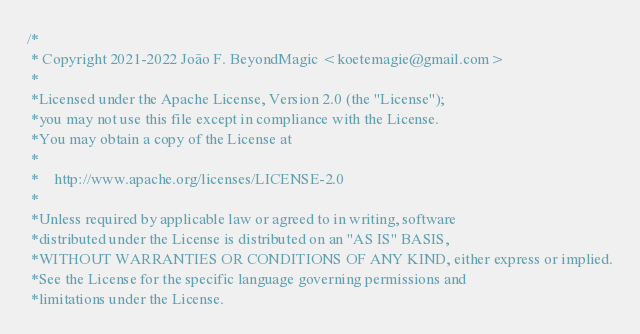<code> <loc_0><loc_0><loc_500><loc_500><_C++_>/*
 * Copyright 2021-2022 João F. BeyondMagic <koetemagie@gmail.com>
 *
 *Licensed under the Apache License, Version 2.0 (the "License");
 *you may not use this file except in compliance with the License.
 *You may obtain a copy of the License at
 *
 *    http://www.apache.org/licenses/LICENSE-2.0
 *
 *Unless required by applicable law or agreed to in writing, software
 *distributed under the License is distributed on an "AS IS" BASIS,
 *WITHOUT WARRANTIES OR CONDITIONS OF ANY KIND, either express or implied.
 *See the License for the specific language governing permissions and
 *limitations under the License.</code> 